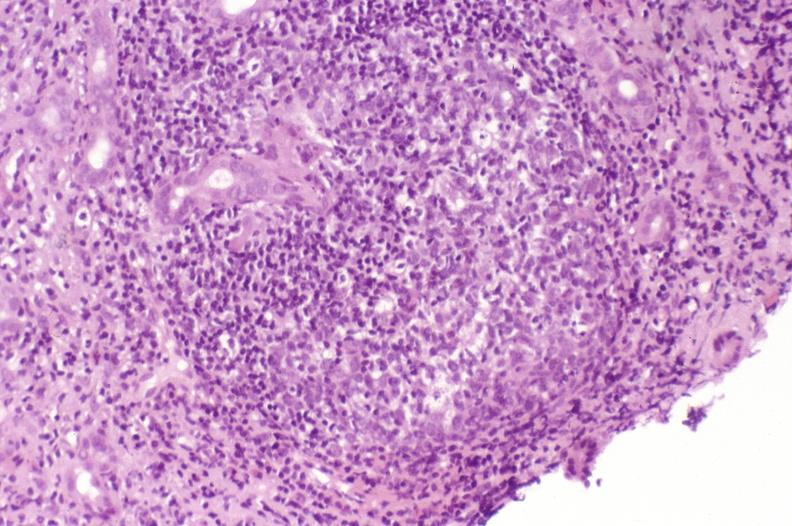s hepatobiliary present?
Answer the question using a single word or phrase. Yes 